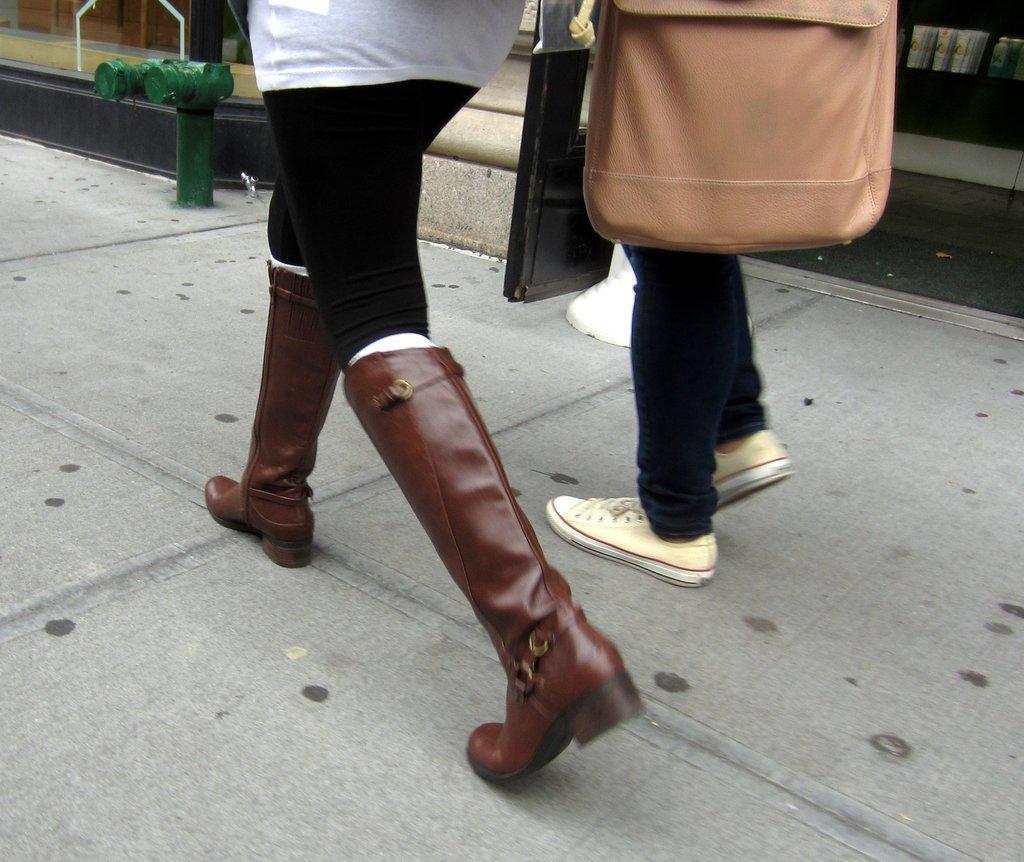How would you summarize this image in a sentence or two? This image is taken outdoors. At the bottom of the image there is a floor. At the top of the image there is a building. In the middle of the image two persons are walking on the floor. 